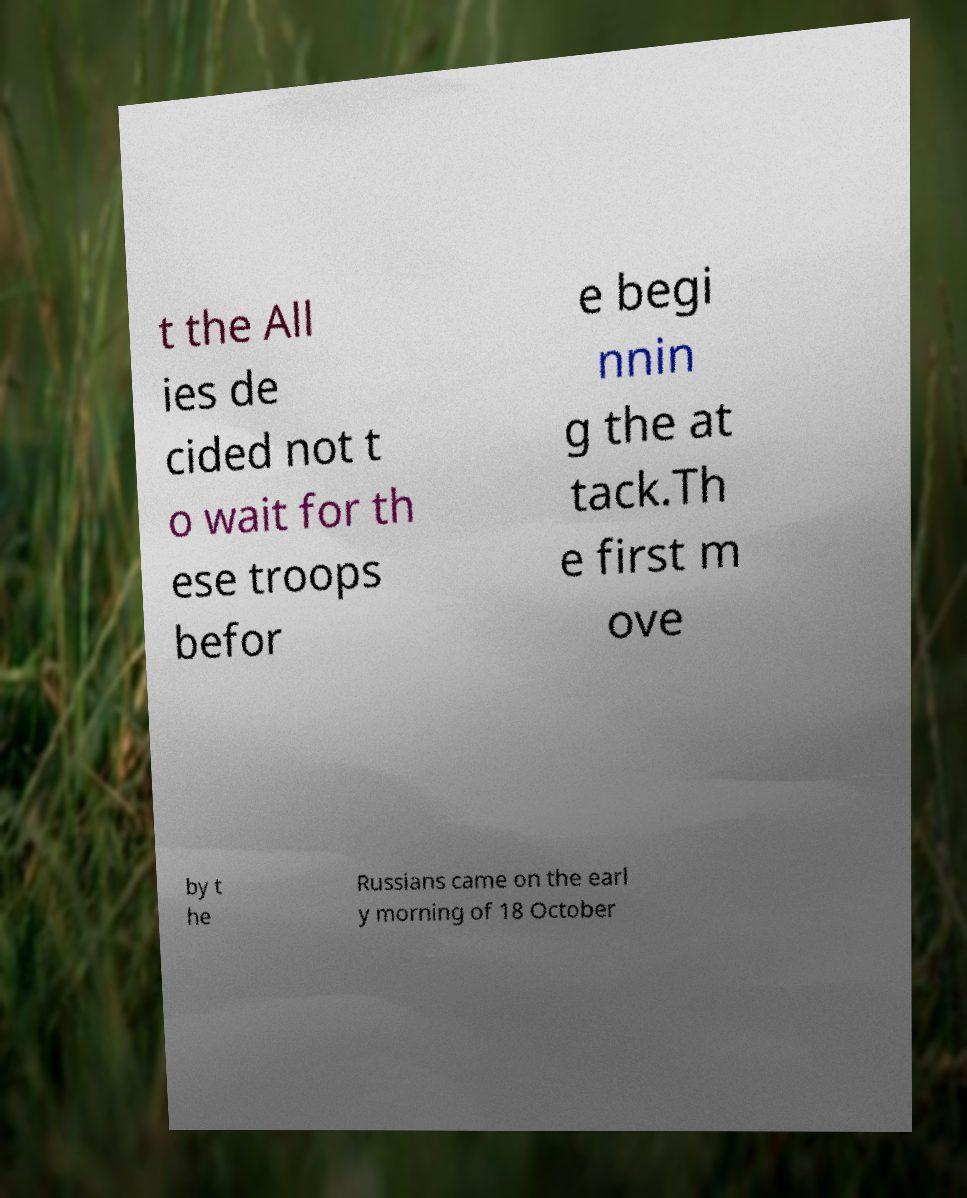Can you accurately transcribe the text from the provided image for me? t the All ies de cided not t o wait for th ese troops befor e begi nnin g the at tack.Th e first m ove by t he Russians came on the earl y morning of 18 October 